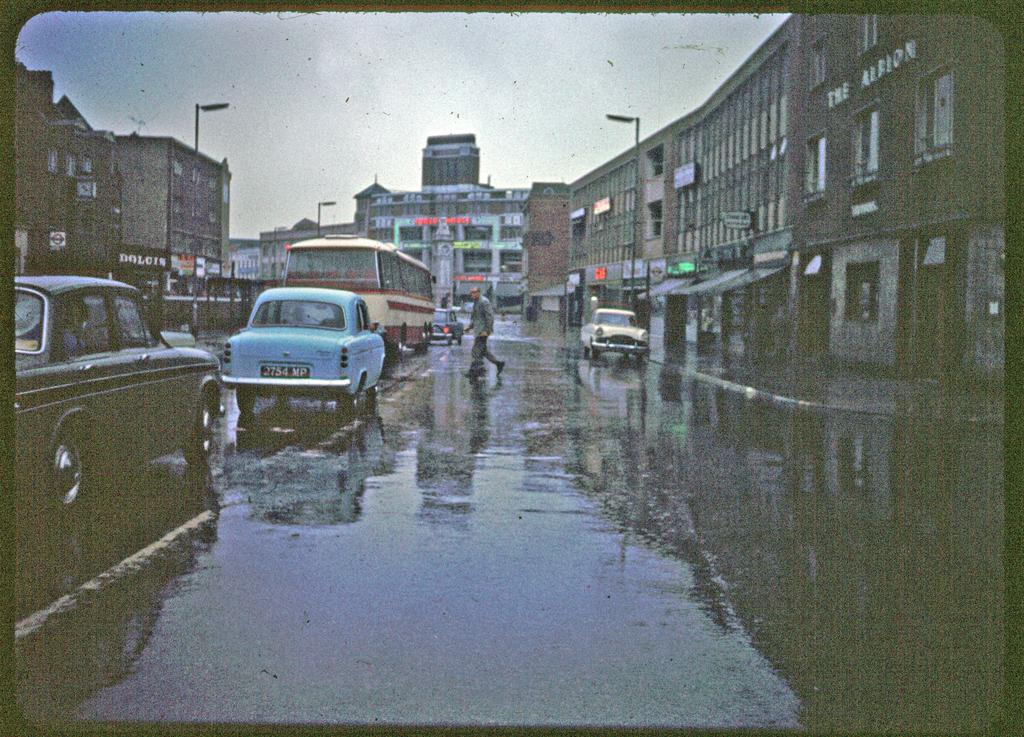What type of structures can be seen in the image? There are buildings in the image. What feature of the buildings is visible? There are windows visible in the image. What type of street furniture can be seen in the image? There are lights-poles in the image. What type of signage is present in the image? There are boards in the image. What part of the natural environment is visible in the image? The sky is visible in the image. What type of transportation is present in the image? There are vehicles on the road in the image. Is there any human presence in the image? Yes, one person is walking on the road in the image. How many volleyballs are being played with on the road in the image? There are no volleyballs present in the image. What is the amount of babies visible in the image? There are no babies visible in the image. 